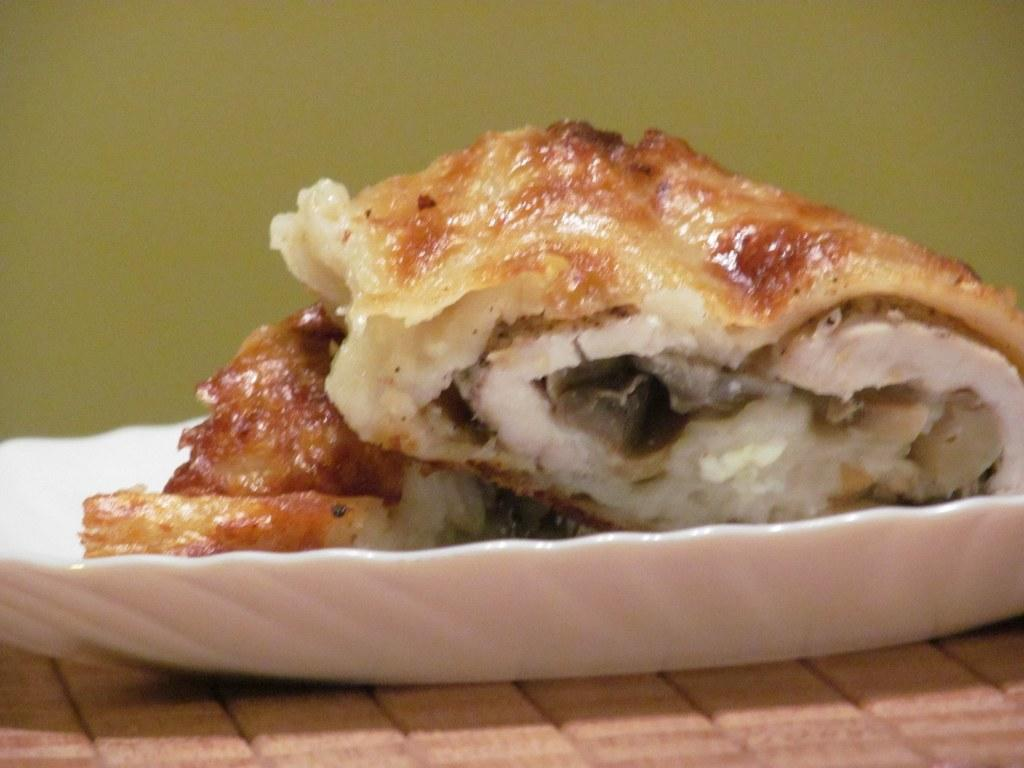What is on the plate that is visible in the image? There is food on a plate in the image. Where is the plate located in the image? The plate is placed on a surface in the image. What can be seen in the background of the image? There is a wall in the background of the image. What type of engine is visible in the image? There is no engine present in the image. How many legs does the food on the plate have? The food on the plate does not have legs, as it is not a living creature. 